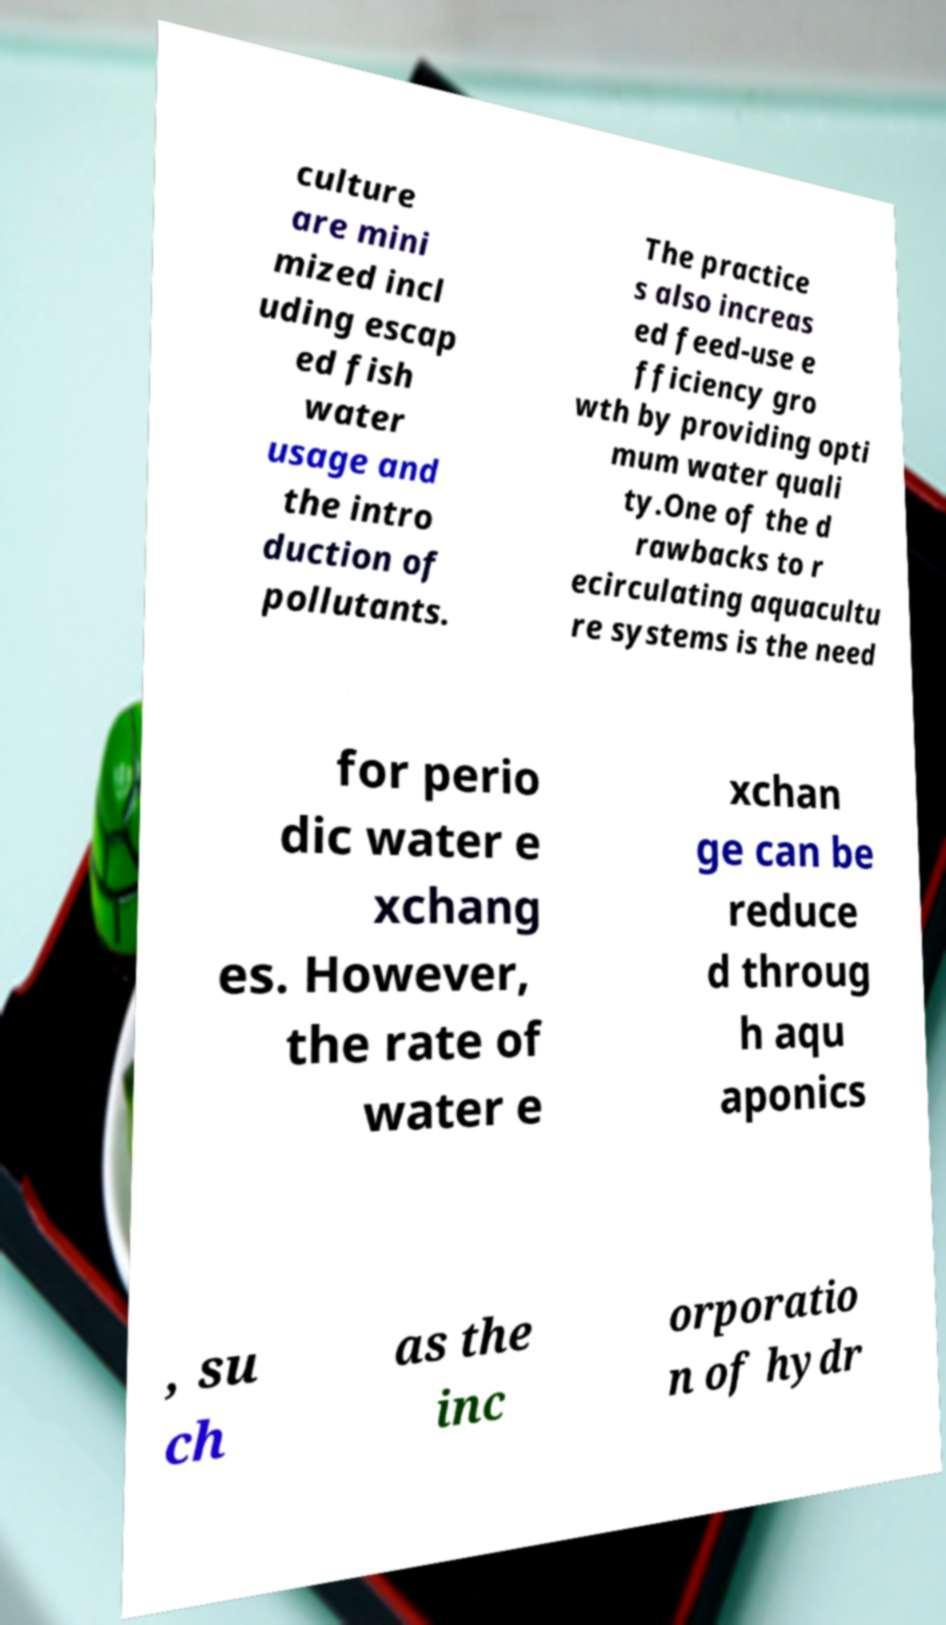I need the written content from this picture converted into text. Can you do that? culture are mini mized incl uding escap ed fish water usage and the intro duction of pollutants. The practice s also increas ed feed-use e fficiency gro wth by providing opti mum water quali ty.One of the d rawbacks to r ecirculating aquacultu re systems is the need for perio dic water e xchang es. However, the rate of water e xchan ge can be reduce d throug h aqu aponics , su ch as the inc orporatio n of hydr 